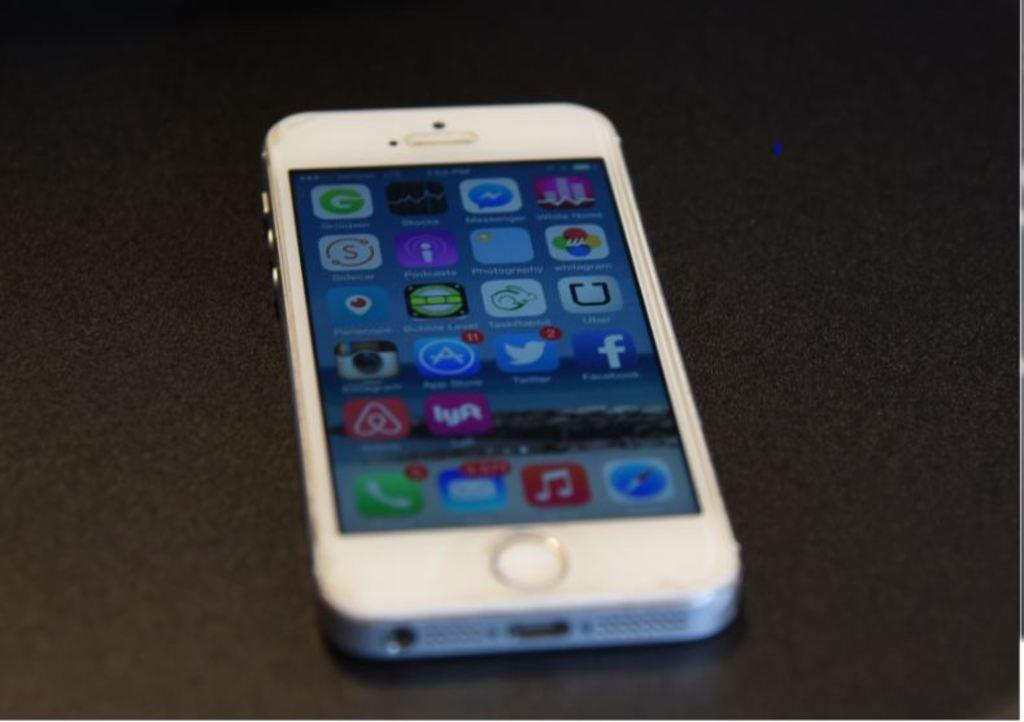<image>
Write a terse but informative summary of the picture. Iphone with the home screen showing missed calls and apps 